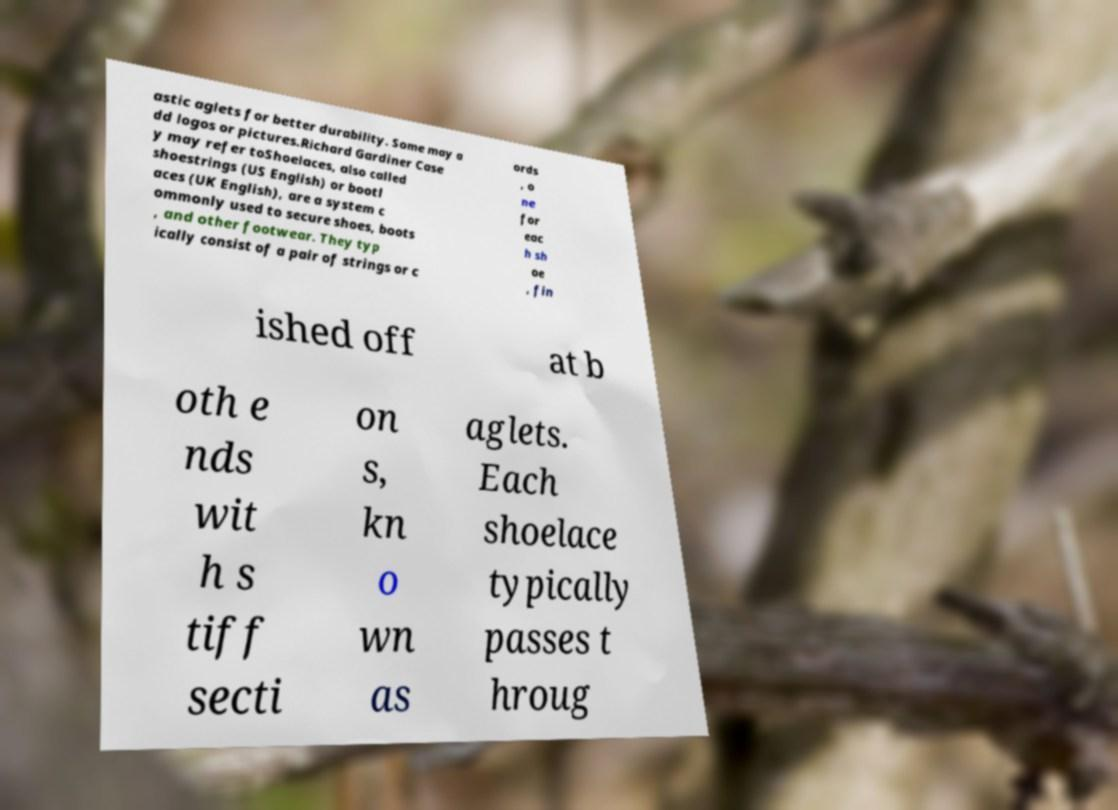Please identify and transcribe the text found in this image. astic aglets for better durability. Some may a dd logos or pictures.Richard Gardiner Case y may refer toShoelaces, also called shoestrings (US English) or bootl aces (UK English), are a system c ommonly used to secure shoes, boots , and other footwear. They typ ically consist of a pair of strings or c ords , o ne for eac h sh oe , fin ished off at b oth e nds wit h s tiff secti on s, kn o wn as aglets. Each shoelace typically passes t hroug 